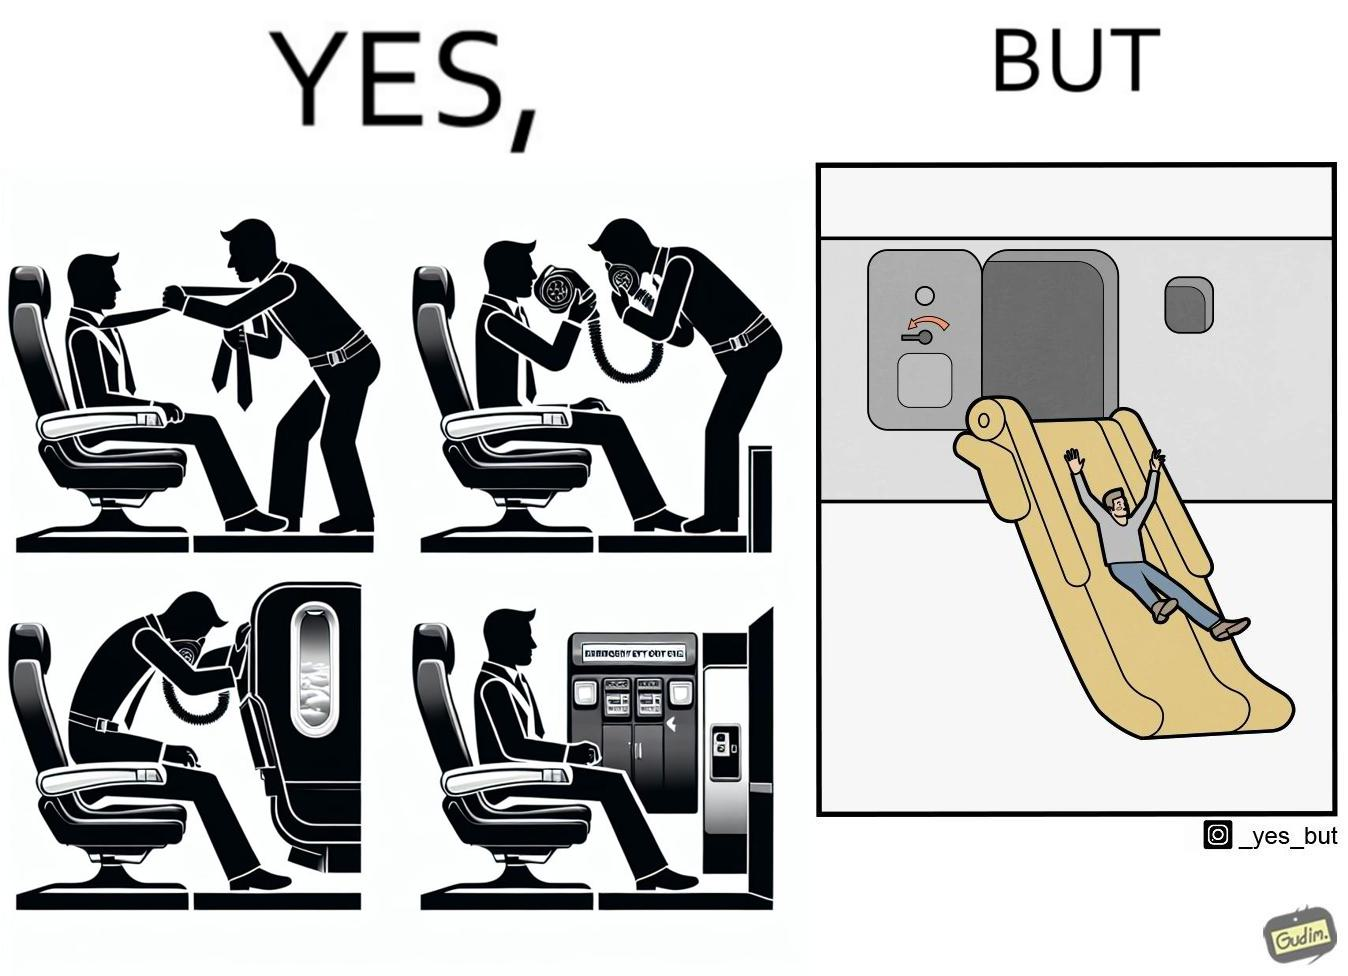Describe what you see in the left and right parts of this image. In the left part of the image: They are images of what one should do in an airplane in case of an imminent collision and fire In the right part of the image: It shows a man jumping out of an airplane in case of an emergency and using the emergency inflatable slides 